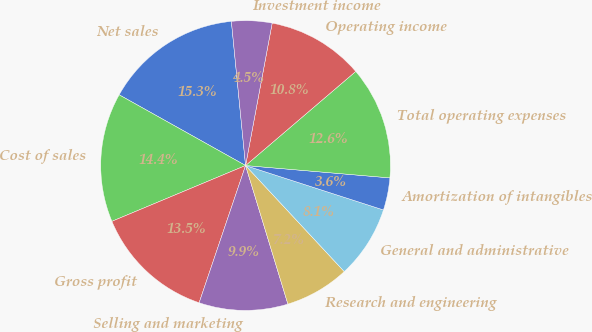Convert chart. <chart><loc_0><loc_0><loc_500><loc_500><pie_chart><fcel>Net sales<fcel>Cost of sales<fcel>Gross profit<fcel>Selling and marketing<fcel>Research and engineering<fcel>General and administrative<fcel>Amortization of intangibles<fcel>Total operating expenses<fcel>Operating income<fcel>Investment income<nl><fcel>15.32%<fcel>14.41%<fcel>13.51%<fcel>9.91%<fcel>7.21%<fcel>8.11%<fcel>3.6%<fcel>12.61%<fcel>10.81%<fcel>4.5%<nl></chart> 